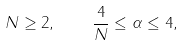Convert formula to latex. <formula><loc_0><loc_0><loc_500><loc_500>N \geq 2 , \quad \frac { 4 } { N } \leq \alpha \leq 4 ,</formula> 